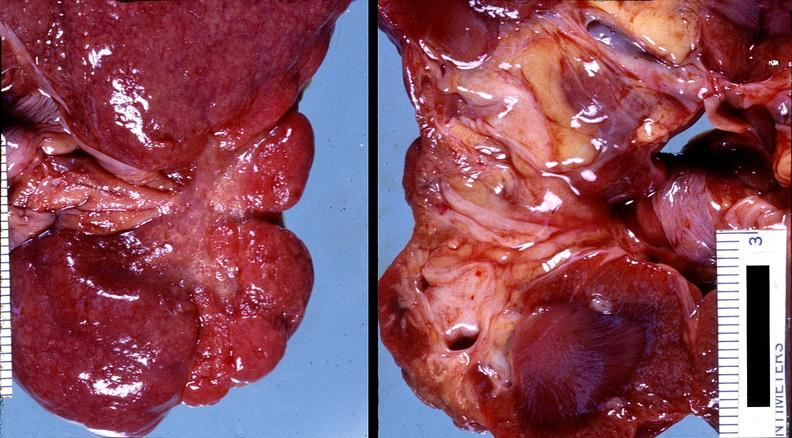where is this?
Answer the question using a single word or phrase. Urinary 